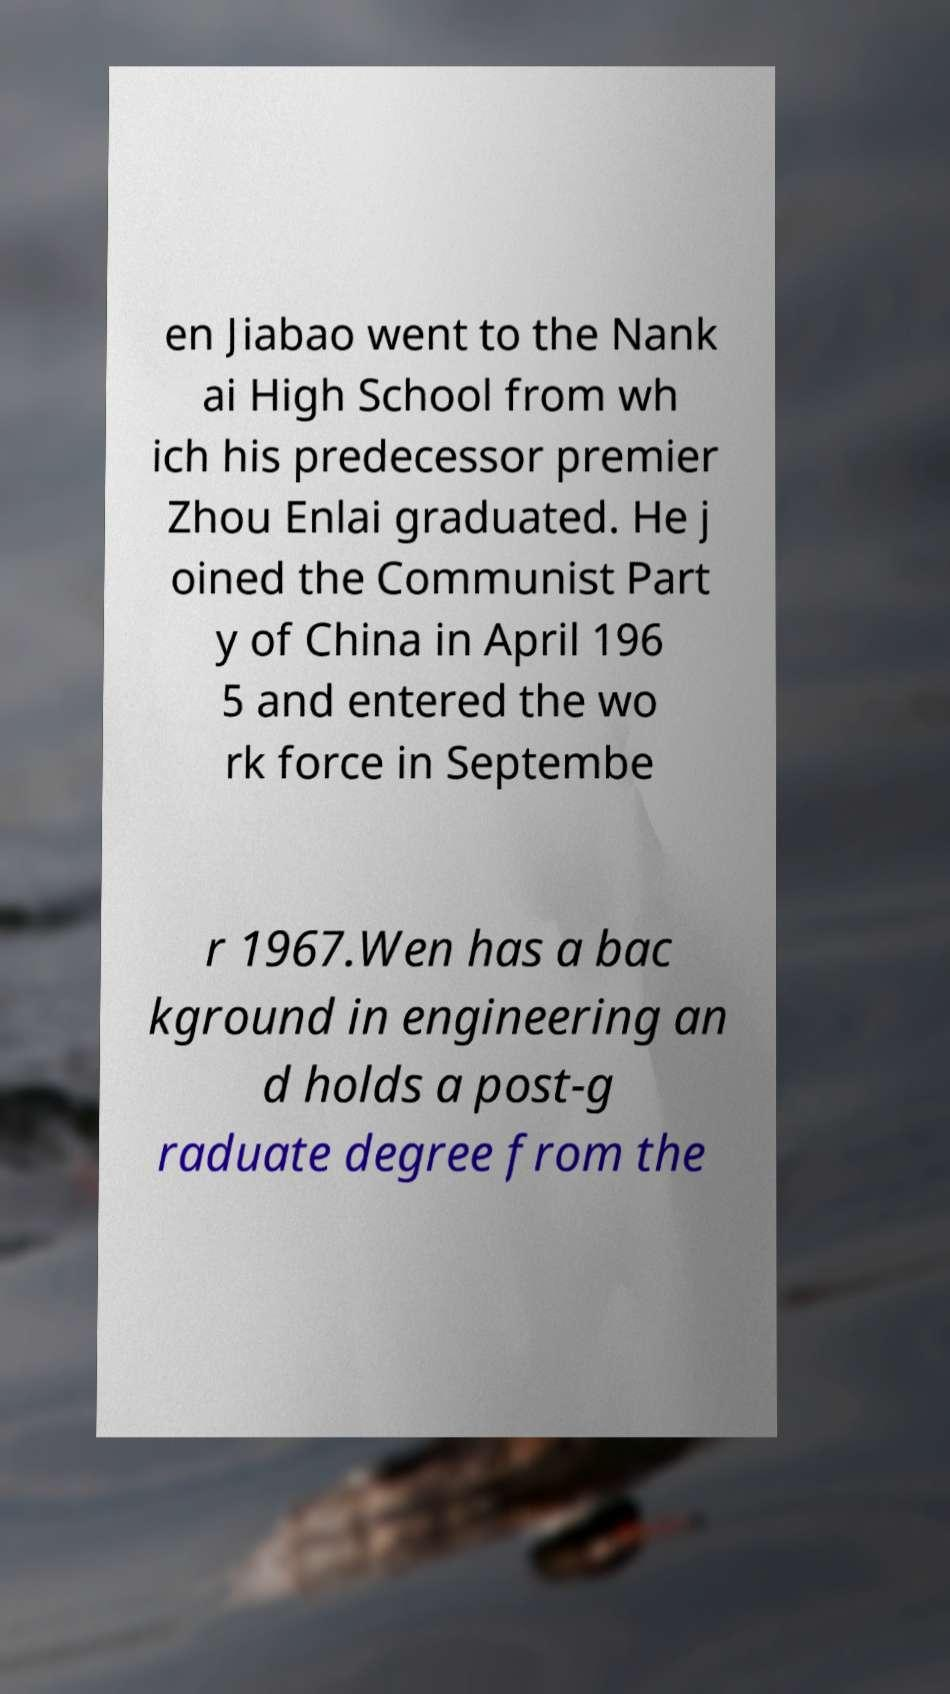There's text embedded in this image that I need extracted. Can you transcribe it verbatim? en Jiabao went to the Nank ai High School from wh ich his predecessor premier Zhou Enlai graduated. He j oined the Communist Part y of China in April 196 5 and entered the wo rk force in Septembe r 1967.Wen has a bac kground in engineering an d holds a post-g raduate degree from the 